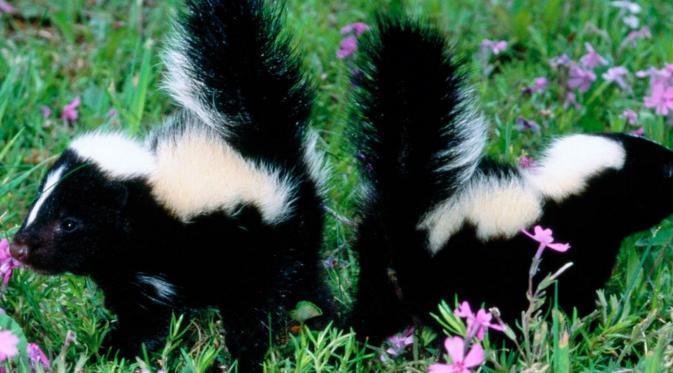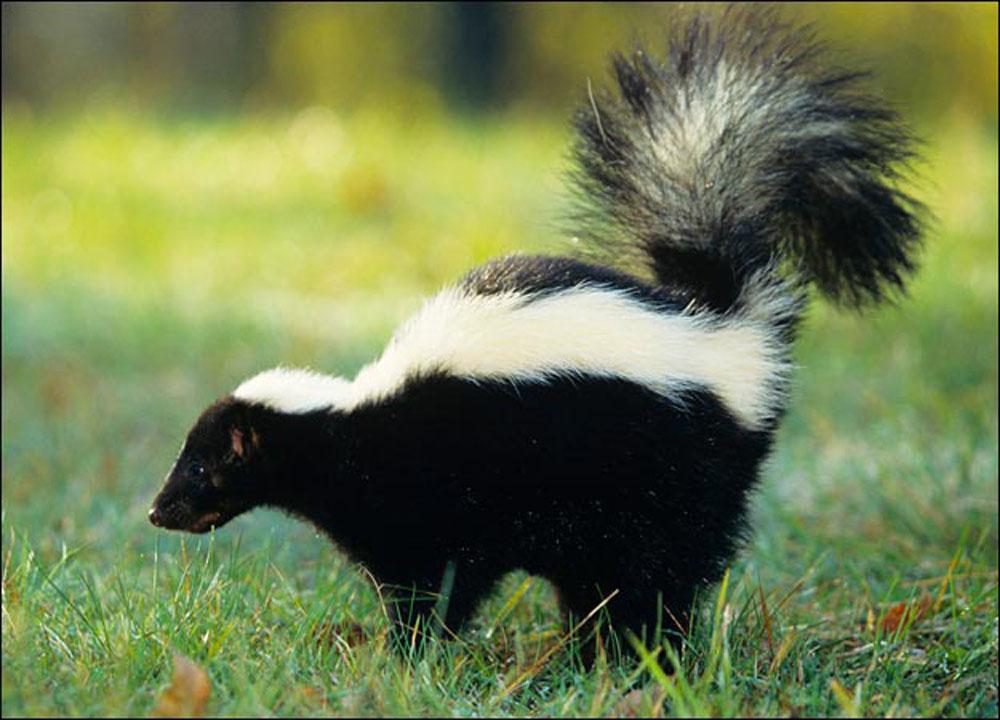The first image is the image on the left, the second image is the image on the right. Considering the images on both sides, is "There are three skunks." valid? Answer yes or no. Yes. The first image is the image on the left, the second image is the image on the right. For the images displayed, is the sentence "There are three skunks in total." factually correct? Answer yes or no. Yes. 